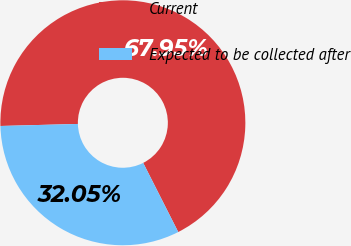Convert chart to OTSL. <chart><loc_0><loc_0><loc_500><loc_500><pie_chart><fcel>Current<fcel>Expected to be collected after<nl><fcel>67.95%<fcel>32.05%<nl></chart> 